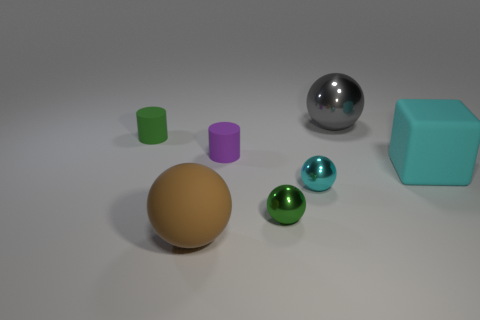Subtract all shiny spheres. How many spheres are left? 1 Subtract all cyan spheres. How many spheres are left? 3 Subtract 1 balls. How many balls are left? 3 Subtract all blocks. How many objects are left? 6 Add 3 green objects. How many objects exist? 10 Add 5 small blue matte balls. How many small blue matte balls exist? 5 Subtract 0 gray cylinders. How many objects are left? 7 Subtract all yellow spheres. Subtract all blue blocks. How many spheres are left? 4 Subtract all big cylinders. Subtract all tiny cyan balls. How many objects are left? 6 Add 6 green metal spheres. How many green metal spheres are left? 7 